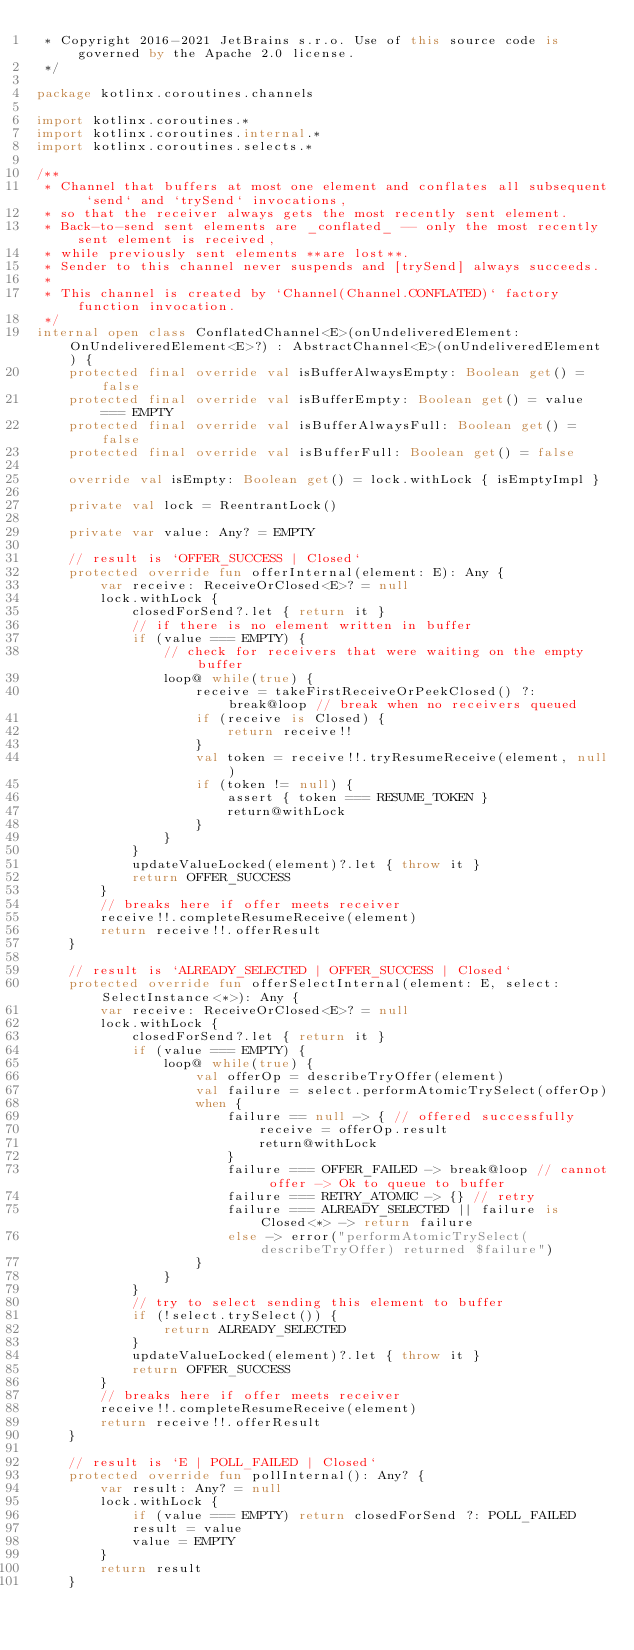<code> <loc_0><loc_0><loc_500><loc_500><_Kotlin_> * Copyright 2016-2021 JetBrains s.r.o. Use of this source code is governed by the Apache 2.0 license.
 */

package kotlinx.coroutines.channels

import kotlinx.coroutines.*
import kotlinx.coroutines.internal.*
import kotlinx.coroutines.selects.*

/**
 * Channel that buffers at most one element and conflates all subsequent `send` and `trySend` invocations,
 * so that the receiver always gets the most recently sent element.
 * Back-to-send sent elements are _conflated_ -- only the most recently sent element is received,
 * while previously sent elements **are lost**.
 * Sender to this channel never suspends and [trySend] always succeeds.
 *
 * This channel is created by `Channel(Channel.CONFLATED)` factory function invocation.
 */
internal open class ConflatedChannel<E>(onUndeliveredElement: OnUndeliveredElement<E>?) : AbstractChannel<E>(onUndeliveredElement) {
    protected final override val isBufferAlwaysEmpty: Boolean get() = false
    protected final override val isBufferEmpty: Boolean get() = value === EMPTY
    protected final override val isBufferAlwaysFull: Boolean get() = false
    protected final override val isBufferFull: Boolean get() = false

    override val isEmpty: Boolean get() = lock.withLock { isEmptyImpl }

    private val lock = ReentrantLock()

    private var value: Any? = EMPTY

    // result is `OFFER_SUCCESS | Closed`
    protected override fun offerInternal(element: E): Any {
        var receive: ReceiveOrClosed<E>? = null
        lock.withLock {
            closedForSend?.let { return it }
            // if there is no element written in buffer
            if (value === EMPTY) {
                // check for receivers that were waiting on the empty buffer
                loop@ while(true) {
                    receive = takeFirstReceiveOrPeekClosed() ?: break@loop // break when no receivers queued
                    if (receive is Closed) {
                        return receive!!
                    }
                    val token = receive!!.tryResumeReceive(element, null)
                    if (token != null) {
                        assert { token === RESUME_TOKEN }
                        return@withLock
                    }
                }
            }
            updateValueLocked(element)?.let { throw it }
            return OFFER_SUCCESS
        }
        // breaks here if offer meets receiver
        receive!!.completeResumeReceive(element)
        return receive!!.offerResult
    }

    // result is `ALREADY_SELECTED | OFFER_SUCCESS | Closed`
    protected override fun offerSelectInternal(element: E, select: SelectInstance<*>): Any {
        var receive: ReceiveOrClosed<E>? = null
        lock.withLock {
            closedForSend?.let { return it }
            if (value === EMPTY) {
                loop@ while(true) {
                    val offerOp = describeTryOffer(element)
                    val failure = select.performAtomicTrySelect(offerOp)
                    when {
                        failure == null -> { // offered successfully
                            receive = offerOp.result
                            return@withLock
                        }
                        failure === OFFER_FAILED -> break@loop // cannot offer -> Ok to queue to buffer
                        failure === RETRY_ATOMIC -> {} // retry
                        failure === ALREADY_SELECTED || failure is Closed<*> -> return failure
                        else -> error("performAtomicTrySelect(describeTryOffer) returned $failure")
                    }
                }
            }
            // try to select sending this element to buffer
            if (!select.trySelect()) {
                return ALREADY_SELECTED
            }
            updateValueLocked(element)?.let { throw it }
            return OFFER_SUCCESS
        }
        // breaks here if offer meets receiver
        receive!!.completeResumeReceive(element)
        return receive!!.offerResult
    }

    // result is `E | POLL_FAILED | Closed`
    protected override fun pollInternal(): Any? {
        var result: Any? = null
        lock.withLock {
            if (value === EMPTY) return closedForSend ?: POLL_FAILED
            result = value
            value = EMPTY
        }
        return result
    }
</code> 